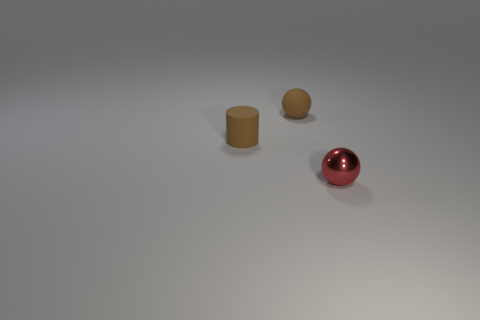There is a tiny object that is in front of the small brown object that is left of the small sphere behind the red shiny object; what is its material?
Offer a terse response. Metal. What is the material of the object right of the sphere that is behind the red metallic sphere?
Offer a very short reply. Metal. There is a ball behind the small red object; does it have the same size as the red shiny thing in front of the rubber ball?
Offer a very short reply. Yes. Is there anything else that is the same material as the small brown ball?
Keep it short and to the point. Yes. How many tiny things are matte spheres or red spheres?
Your answer should be compact. 2. How many objects are either tiny matte things to the right of the brown rubber cylinder or small red matte cylinders?
Your answer should be compact. 1. Does the rubber cylinder have the same color as the shiny thing?
Give a very brief answer. No. What number of other objects are the same shape as the tiny red thing?
Keep it short and to the point. 1. How many green things are either rubber things or tiny things?
Offer a very short reply. 0. The small thing that is made of the same material as the cylinder is what color?
Make the answer very short. Brown. 